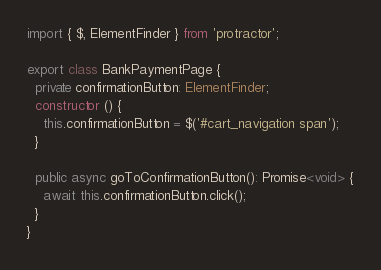<code> <loc_0><loc_0><loc_500><loc_500><_TypeScript_>import { $, ElementFinder } from 'protractor';

export class BankPaymentPage {
  private confirmationButton: ElementFinder;
  constructor () {
    this.confirmationButton = $('#cart_navigation span');
  }

  public async goToConfirmationButton(): Promise<void> {
    await this.confirmationButton.click();
  }
}
</code> 